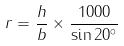<formula> <loc_0><loc_0><loc_500><loc_500>r = \frac { h } { b } \times \frac { 1 0 0 0 } { \sin 2 0 ^ { \circ } }</formula> 